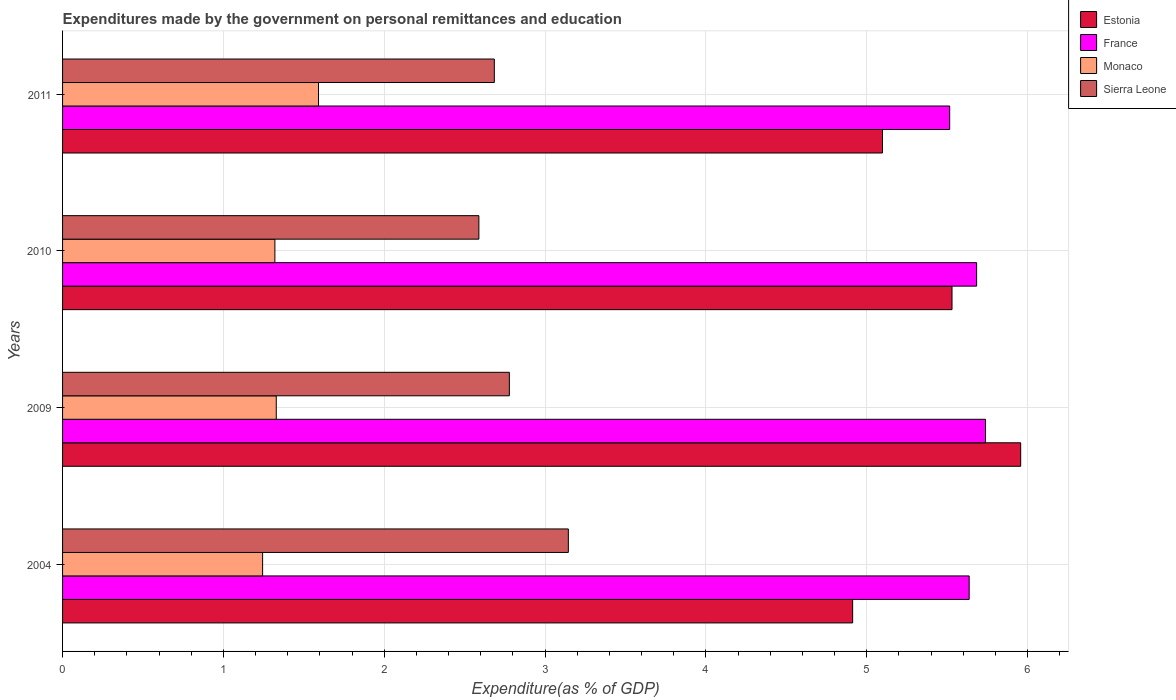How many groups of bars are there?
Give a very brief answer. 4. Are the number of bars per tick equal to the number of legend labels?
Give a very brief answer. Yes. How many bars are there on the 2nd tick from the bottom?
Offer a very short reply. 4. What is the expenditures made by the government on personal remittances and education in Estonia in 2011?
Offer a very short reply. 5.1. Across all years, what is the maximum expenditures made by the government on personal remittances and education in Sierra Leone?
Ensure brevity in your answer.  3.14. Across all years, what is the minimum expenditures made by the government on personal remittances and education in Sierra Leone?
Make the answer very short. 2.59. In which year was the expenditures made by the government on personal remittances and education in France maximum?
Provide a short and direct response. 2009. What is the total expenditures made by the government on personal remittances and education in Estonia in the graph?
Make the answer very short. 21.5. What is the difference between the expenditures made by the government on personal remittances and education in Sierra Leone in 2004 and that in 2011?
Your answer should be compact. 0.46. What is the difference between the expenditures made by the government on personal remittances and education in Sierra Leone in 2004 and the expenditures made by the government on personal remittances and education in Monaco in 2011?
Offer a terse response. 1.55. What is the average expenditures made by the government on personal remittances and education in Monaco per year?
Provide a succinct answer. 1.37. In the year 2004, what is the difference between the expenditures made by the government on personal remittances and education in France and expenditures made by the government on personal remittances and education in Monaco?
Your answer should be very brief. 4.39. What is the ratio of the expenditures made by the government on personal remittances and education in Sierra Leone in 2004 to that in 2009?
Offer a very short reply. 1.13. What is the difference between the highest and the second highest expenditures made by the government on personal remittances and education in France?
Your answer should be compact. 0.06. What is the difference between the highest and the lowest expenditures made by the government on personal remittances and education in Estonia?
Provide a succinct answer. 1.04. Is it the case that in every year, the sum of the expenditures made by the government on personal remittances and education in Monaco and expenditures made by the government on personal remittances and education in Estonia is greater than the sum of expenditures made by the government on personal remittances and education in France and expenditures made by the government on personal remittances and education in Sierra Leone?
Offer a very short reply. Yes. What does the 3rd bar from the top in 2010 represents?
Your answer should be very brief. France. What does the 1st bar from the bottom in 2009 represents?
Your answer should be very brief. Estonia. Are all the bars in the graph horizontal?
Offer a terse response. Yes. What is the difference between two consecutive major ticks on the X-axis?
Make the answer very short. 1. Are the values on the major ticks of X-axis written in scientific E-notation?
Give a very brief answer. No. Does the graph contain any zero values?
Provide a succinct answer. No. Where does the legend appear in the graph?
Your answer should be compact. Top right. How many legend labels are there?
Provide a short and direct response. 4. How are the legend labels stacked?
Your response must be concise. Vertical. What is the title of the graph?
Give a very brief answer. Expenditures made by the government on personal remittances and education. What is the label or title of the X-axis?
Offer a very short reply. Expenditure(as % of GDP). What is the Expenditure(as % of GDP) of Estonia in 2004?
Keep it short and to the point. 4.91. What is the Expenditure(as % of GDP) of France in 2004?
Provide a short and direct response. 5.64. What is the Expenditure(as % of GDP) of Monaco in 2004?
Offer a very short reply. 1.24. What is the Expenditure(as % of GDP) in Sierra Leone in 2004?
Provide a short and direct response. 3.14. What is the Expenditure(as % of GDP) in Estonia in 2009?
Offer a very short reply. 5.96. What is the Expenditure(as % of GDP) in France in 2009?
Provide a short and direct response. 5.74. What is the Expenditure(as % of GDP) in Monaco in 2009?
Offer a very short reply. 1.33. What is the Expenditure(as % of GDP) of Sierra Leone in 2009?
Keep it short and to the point. 2.78. What is the Expenditure(as % of GDP) in Estonia in 2010?
Keep it short and to the point. 5.53. What is the Expenditure(as % of GDP) of France in 2010?
Give a very brief answer. 5.68. What is the Expenditure(as % of GDP) in Monaco in 2010?
Provide a short and direct response. 1.32. What is the Expenditure(as % of GDP) in Sierra Leone in 2010?
Make the answer very short. 2.59. What is the Expenditure(as % of GDP) in Estonia in 2011?
Provide a short and direct response. 5.1. What is the Expenditure(as % of GDP) of France in 2011?
Your response must be concise. 5.52. What is the Expenditure(as % of GDP) of Monaco in 2011?
Your answer should be very brief. 1.59. What is the Expenditure(as % of GDP) of Sierra Leone in 2011?
Your response must be concise. 2.68. Across all years, what is the maximum Expenditure(as % of GDP) of Estonia?
Provide a succinct answer. 5.96. Across all years, what is the maximum Expenditure(as % of GDP) in France?
Provide a succinct answer. 5.74. Across all years, what is the maximum Expenditure(as % of GDP) of Monaco?
Your answer should be compact. 1.59. Across all years, what is the maximum Expenditure(as % of GDP) in Sierra Leone?
Ensure brevity in your answer.  3.14. Across all years, what is the minimum Expenditure(as % of GDP) of Estonia?
Your answer should be compact. 4.91. Across all years, what is the minimum Expenditure(as % of GDP) in France?
Give a very brief answer. 5.52. Across all years, what is the minimum Expenditure(as % of GDP) in Monaco?
Your response must be concise. 1.24. Across all years, what is the minimum Expenditure(as % of GDP) of Sierra Leone?
Offer a very short reply. 2.59. What is the total Expenditure(as % of GDP) of Estonia in the graph?
Provide a short and direct response. 21.5. What is the total Expenditure(as % of GDP) of France in the graph?
Make the answer very short. 22.57. What is the total Expenditure(as % of GDP) of Monaco in the graph?
Make the answer very short. 5.48. What is the total Expenditure(as % of GDP) in Sierra Leone in the graph?
Your answer should be compact. 11.2. What is the difference between the Expenditure(as % of GDP) of Estonia in 2004 and that in 2009?
Give a very brief answer. -1.04. What is the difference between the Expenditure(as % of GDP) of France in 2004 and that in 2009?
Make the answer very short. -0.1. What is the difference between the Expenditure(as % of GDP) of Monaco in 2004 and that in 2009?
Your answer should be compact. -0.08. What is the difference between the Expenditure(as % of GDP) of Sierra Leone in 2004 and that in 2009?
Give a very brief answer. 0.37. What is the difference between the Expenditure(as % of GDP) of Estonia in 2004 and that in 2010?
Provide a succinct answer. -0.62. What is the difference between the Expenditure(as % of GDP) in France in 2004 and that in 2010?
Provide a short and direct response. -0.05. What is the difference between the Expenditure(as % of GDP) of Monaco in 2004 and that in 2010?
Your response must be concise. -0.08. What is the difference between the Expenditure(as % of GDP) of Sierra Leone in 2004 and that in 2010?
Offer a terse response. 0.56. What is the difference between the Expenditure(as % of GDP) in Estonia in 2004 and that in 2011?
Your response must be concise. -0.19. What is the difference between the Expenditure(as % of GDP) of France in 2004 and that in 2011?
Keep it short and to the point. 0.12. What is the difference between the Expenditure(as % of GDP) in Monaco in 2004 and that in 2011?
Keep it short and to the point. -0.35. What is the difference between the Expenditure(as % of GDP) in Sierra Leone in 2004 and that in 2011?
Provide a short and direct response. 0.46. What is the difference between the Expenditure(as % of GDP) in Estonia in 2009 and that in 2010?
Keep it short and to the point. 0.43. What is the difference between the Expenditure(as % of GDP) of France in 2009 and that in 2010?
Your response must be concise. 0.06. What is the difference between the Expenditure(as % of GDP) of Monaco in 2009 and that in 2010?
Offer a very short reply. 0.01. What is the difference between the Expenditure(as % of GDP) in Sierra Leone in 2009 and that in 2010?
Your response must be concise. 0.19. What is the difference between the Expenditure(as % of GDP) in Estonia in 2009 and that in 2011?
Give a very brief answer. 0.86. What is the difference between the Expenditure(as % of GDP) in France in 2009 and that in 2011?
Give a very brief answer. 0.22. What is the difference between the Expenditure(as % of GDP) of Monaco in 2009 and that in 2011?
Provide a short and direct response. -0.26. What is the difference between the Expenditure(as % of GDP) in Sierra Leone in 2009 and that in 2011?
Your answer should be very brief. 0.09. What is the difference between the Expenditure(as % of GDP) in Estonia in 2010 and that in 2011?
Give a very brief answer. 0.43. What is the difference between the Expenditure(as % of GDP) in France in 2010 and that in 2011?
Ensure brevity in your answer.  0.17. What is the difference between the Expenditure(as % of GDP) in Monaco in 2010 and that in 2011?
Offer a terse response. -0.27. What is the difference between the Expenditure(as % of GDP) in Sierra Leone in 2010 and that in 2011?
Your answer should be very brief. -0.1. What is the difference between the Expenditure(as % of GDP) of Estonia in 2004 and the Expenditure(as % of GDP) of France in 2009?
Make the answer very short. -0.83. What is the difference between the Expenditure(as % of GDP) in Estonia in 2004 and the Expenditure(as % of GDP) in Monaco in 2009?
Ensure brevity in your answer.  3.58. What is the difference between the Expenditure(as % of GDP) in Estonia in 2004 and the Expenditure(as % of GDP) in Sierra Leone in 2009?
Make the answer very short. 2.13. What is the difference between the Expenditure(as % of GDP) in France in 2004 and the Expenditure(as % of GDP) in Monaco in 2009?
Provide a succinct answer. 4.31. What is the difference between the Expenditure(as % of GDP) in France in 2004 and the Expenditure(as % of GDP) in Sierra Leone in 2009?
Provide a succinct answer. 2.86. What is the difference between the Expenditure(as % of GDP) of Monaco in 2004 and the Expenditure(as % of GDP) of Sierra Leone in 2009?
Keep it short and to the point. -1.53. What is the difference between the Expenditure(as % of GDP) in Estonia in 2004 and the Expenditure(as % of GDP) in France in 2010?
Make the answer very short. -0.77. What is the difference between the Expenditure(as % of GDP) in Estonia in 2004 and the Expenditure(as % of GDP) in Monaco in 2010?
Ensure brevity in your answer.  3.59. What is the difference between the Expenditure(as % of GDP) in Estonia in 2004 and the Expenditure(as % of GDP) in Sierra Leone in 2010?
Provide a short and direct response. 2.32. What is the difference between the Expenditure(as % of GDP) in France in 2004 and the Expenditure(as % of GDP) in Monaco in 2010?
Make the answer very short. 4.32. What is the difference between the Expenditure(as % of GDP) of France in 2004 and the Expenditure(as % of GDP) of Sierra Leone in 2010?
Your answer should be very brief. 3.05. What is the difference between the Expenditure(as % of GDP) in Monaco in 2004 and the Expenditure(as % of GDP) in Sierra Leone in 2010?
Offer a very short reply. -1.34. What is the difference between the Expenditure(as % of GDP) of Estonia in 2004 and the Expenditure(as % of GDP) of France in 2011?
Provide a short and direct response. -0.6. What is the difference between the Expenditure(as % of GDP) in Estonia in 2004 and the Expenditure(as % of GDP) in Monaco in 2011?
Offer a terse response. 3.32. What is the difference between the Expenditure(as % of GDP) in Estonia in 2004 and the Expenditure(as % of GDP) in Sierra Leone in 2011?
Provide a short and direct response. 2.23. What is the difference between the Expenditure(as % of GDP) in France in 2004 and the Expenditure(as % of GDP) in Monaco in 2011?
Your answer should be very brief. 4.05. What is the difference between the Expenditure(as % of GDP) of France in 2004 and the Expenditure(as % of GDP) of Sierra Leone in 2011?
Ensure brevity in your answer.  2.95. What is the difference between the Expenditure(as % of GDP) in Monaco in 2004 and the Expenditure(as % of GDP) in Sierra Leone in 2011?
Provide a short and direct response. -1.44. What is the difference between the Expenditure(as % of GDP) in Estonia in 2009 and the Expenditure(as % of GDP) in France in 2010?
Make the answer very short. 0.27. What is the difference between the Expenditure(as % of GDP) of Estonia in 2009 and the Expenditure(as % of GDP) of Monaco in 2010?
Offer a terse response. 4.64. What is the difference between the Expenditure(as % of GDP) in Estonia in 2009 and the Expenditure(as % of GDP) in Sierra Leone in 2010?
Your answer should be compact. 3.37. What is the difference between the Expenditure(as % of GDP) of France in 2009 and the Expenditure(as % of GDP) of Monaco in 2010?
Provide a succinct answer. 4.42. What is the difference between the Expenditure(as % of GDP) of France in 2009 and the Expenditure(as % of GDP) of Sierra Leone in 2010?
Ensure brevity in your answer.  3.15. What is the difference between the Expenditure(as % of GDP) of Monaco in 2009 and the Expenditure(as % of GDP) of Sierra Leone in 2010?
Ensure brevity in your answer.  -1.26. What is the difference between the Expenditure(as % of GDP) of Estonia in 2009 and the Expenditure(as % of GDP) of France in 2011?
Provide a short and direct response. 0.44. What is the difference between the Expenditure(as % of GDP) in Estonia in 2009 and the Expenditure(as % of GDP) in Monaco in 2011?
Offer a very short reply. 4.37. What is the difference between the Expenditure(as % of GDP) of Estonia in 2009 and the Expenditure(as % of GDP) of Sierra Leone in 2011?
Offer a terse response. 3.27. What is the difference between the Expenditure(as % of GDP) in France in 2009 and the Expenditure(as % of GDP) in Monaco in 2011?
Your answer should be compact. 4.15. What is the difference between the Expenditure(as % of GDP) of France in 2009 and the Expenditure(as % of GDP) of Sierra Leone in 2011?
Provide a succinct answer. 3.05. What is the difference between the Expenditure(as % of GDP) of Monaco in 2009 and the Expenditure(as % of GDP) of Sierra Leone in 2011?
Give a very brief answer. -1.36. What is the difference between the Expenditure(as % of GDP) in Estonia in 2010 and the Expenditure(as % of GDP) in France in 2011?
Your response must be concise. 0.01. What is the difference between the Expenditure(as % of GDP) in Estonia in 2010 and the Expenditure(as % of GDP) in Monaco in 2011?
Your answer should be compact. 3.94. What is the difference between the Expenditure(as % of GDP) of Estonia in 2010 and the Expenditure(as % of GDP) of Sierra Leone in 2011?
Give a very brief answer. 2.85. What is the difference between the Expenditure(as % of GDP) in France in 2010 and the Expenditure(as % of GDP) in Monaco in 2011?
Your response must be concise. 4.09. What is the difference between the Expenditure(as % of GDP) of France in 2010 and the Expenditure(as % of GDP) of Sierra Leone in 2011?
Keep it short and to the point. 3. What is the difference between the Expenditure(as % of GDP) in Monaco in 2010 and the Expenditure(as % of GDP) in Sierra Leone in 2011?
Your response must be concise. -1.36. What is the average Expenditure(as % of GDP) of Estonia per year?
Ensure brevity in your answer.  5.37. What is the average Expenditure(as % of GDP) in France per year?
Make the answer very short. 5.64. What is the average Expenditure(as % of GDP) of Monaco per year?
Keep it short and to the point. 1.37. What is the average Expenditure(as % of GDP) in Sierra Leone per year?
Make the answer very short. 2.8. In the year 2004, what is the difference between the Expenditure(as % of GDP) in Estonia and Expenditure(as % of GDP) in France?
Give a very brief answer. -0.72. In the year 2004, what is the difference between the Expenditure(as % of GDP) of Estonia and Expenditure(as % of GDP) of Monaco?
Your response must be concise. 3.67. In the year 2004, what is the difference between the Expenditure(as % of GDP) in Estonia and Expenditure(as % of GDP) in Sierra Leone?
Keep it short and to the point. 1.77. In the year 2004, what is the difference between the Expenditure(as % of GDP) of France and Expenditure(as % of GDP) of Monaco?
Ensure brevity in your answer.  4.39. In the year 2004, what is the difference between the Expenditure(as % of GDP) of France and Expenditure(as % of GDP) of Sierra Leone?
Ensure brevity in your answer.  2.49. In the year 2004, what is the difference between the Expenditure(as % of GDP) in Monaco and Expenditure(as % of GDP) in Sierra Leone?
Your answer should be compact. -1.9. In the year 2009, what is the difference between the Expenditure(as % of GDP) of Estonia and Expenditure(as % of GDP) of France?
Offer a terse response. 0.22. In the year 2009, what is the difference between the Expenditure(as % of GDP) of Estonia and Expenditure(as % of GDP) of Monaco?
Give a very brief answer. 4.63. In the year 2009, what is the difference between the Expenditure(as % of GDP) in Estonia and Expenditure(as % of GDP) in Sierra Leone?
Your response must be concise. 3.18. In the year 2009, what is the difference between the Expenditure(as % of GDP) of France and Expenditure(as % of GDP) of Monaco?
Provide a succinct answer. 4.41. In the year 2009, what is the difference between the Expenditure(as % of GDP) of France and Expenditure(as % of GDP) of Sierra Leone?
Your answer should be very brief. 2.96. In the year 2009, what is the difference between the Expenditure(as % of GDP) of Monaco and Expenditure(as % of GDP) of Sierra Leone?
Provide a succinct answer. -1.45. In the year 2010, what is the difference between the Expenditure(as % of GDP) of Estonia and Expenditure(as % of GDP) of France?
Offer a very short reply. -0.15. In the year 2010, what is the difference between the Expenditure(as % of GDP) of Estonia and Expenditure(as % of GDP) of Monaco?
Your response must be concise. 4.21. In the year 2010, what is the difference between the Expenditure(as % of GDP) in Estonia and Expenditure(as % of GDP) in Sierra Leone?
Offer a very short reply. 2.94. In the year 2010, what is the difference between the Expenditure(as % of GDP) in France and Expenditure(as % of GDP) in Monaco?
Your answer should be very brief. 4.36. In the year 2010, what is the difference between the Expenditure(as % of GDP) of France and Expenditure(as % of GDP) of Sierra Leone?
Provide a short and direct response. 3.09. In the year 2010, what is the difference between the Expenditure(as % of GDP) in Monaco and Expenditure(as % of GDP) in Sierra Leone?
Your answer should be compact. -1.27. In the year 2011, what is the difference between the Expenditure(as % of GDP) of Estonia and Expenditure(as % of GDP) of France?
Offer a terse response. -0.42. In the year 2011, what is the difference between the Expenditure(as % of GDP) of Estonia and Expenditure(as % of GDP) of Monaco?
Give a very brief answer. 3.51. In the year 2011, what is the difference between the Expenditure(as % of GDP) in Estonia and Expenditure(as % of GDP) in Sierra Leone?
Your answer should be compact. 2.41. In the year 2011, what is the difference between the Expenditure(as % of GDP) of France and Expenditure(as % of GDP) of Monaco?
Make the answer very short. 3.92. In the year 2011, what is the difference between the Expenditure(as % of GDP) of France and Expenditure(as % of GDP) of Sierra Leone?
Your response must be concise. 2.83. In the year 2011, what is the difference between the Expenditure(as % of GDP) of Monaco and Expenditure(as % of GDP) of Sierra Leone?
Provide a succinct answer. -1.09. What is the ratio of the Expenditure(as % of GDP) of Estonia in 2004 to that in 2009?
Make the answer very short. 0.82. What is the ratio of the Expenditure(as % of GDP) of France in 2004 to that in 2009?
Ensure brevity in your answer.  0.98. What is the ratio of the Expenditure(as % of GDP) of Monaco in 2004 to that in 2009?
Keep it short and to the point. 0.94. What is the ratio of the Expenditure(as % of GDP) of Sierra Leone in 2004 to that in 2009?
Offer a very short reply. 1.13. What is the ratio of the Expenditure(as % of GDP) of Estonia in 2004 to that in 2010?
Provide a succinct answer. 0.89. What is the ratio of the Expenditure(as % of GDP) of Monaco in 2004 to that in 2010?
Offer a very short reply. 0.94. What is the ratio of the Expenditure(as % of GDP) in Sierra Leone in 2004 to that in 2010?
Your response must be concise. 1.21. What is the ratio of the Expenditure(as % of GDP) in Estonia in 2004 to that in 2011?
Your answer should be very brief. 0.96. What is the ratio of the Expenditure(as % of GDP) in Monaco in 2004 to that in 2011?
Give a very brief answer. 0.78. What is the ratio of the Expenditure(as % of GDP) of Sierra Leone in 2004 to that in 2011?
Your response must be concise. 1.17. What is the ratio of the Expenditure(as % of GDP) of Estonia in 2009 to that in 2010?
Your answer should be compact. 1.08. What is the ratio of the Expenditure(as % of GDP) of France in 2009 to that in 2010?
Provide a succinct answer. 1.01. What is the ratio of the Expenditure(as % of GDP) of Sierra Leone in 2009 to that in 2010?
Your answer should be very brief. 1.07. What is the ratio of the Expenditure(as % of GDP) in Estonia in 2009 to that in 2011?
Make the answer very short. 1.17. What is the ratio of the Expenditure(as % of GDP) in France in 2009 to that in 2011?
Ensure brevity in your answer.  1.04. What is the ratio of the Expenditure(as % of GDP) in Monaco in 2009 to that in 2011?
Your response must be concise. 0.83. What is the ratio of the Expenditure(as % of GDP) of Sierra Leone in 2009 to that in 2011?
Provide a short and direct response. 1.03. What is the ratio of the Expenditure(as % of GDP) of Estonia in 2010 to that in 2011?
Ensure brevity in your answer.  1.08. What is the ratio of the Expenditure(as % of GDP) in France in 2010 to that in 2011?
Offer a terse response. 1.03. What is the ratio of the Expenditure(as % of GDP) of Monaco in 2010 to that in 2011?
Keep it short and to the point. 0.83. What is the ratio of the Expenditure(as % of GDP) in Sierra Leone in 2010 to that in 2011?
Keep it short and to the point. 0.96. What is the difference between the highest and the second highest Expenditure(as % of GDP) of Estonia?
Offer a very short reply. 0.43. What is the difference between the highest and the second highest Expenditure(as % of GDP) of France?
Ensure brevity in your answer.  0.06. What is the difference between the highest and the second highest Expenditure(as % of GDP) in Monaco?
Offer a terse response. 0.26. What is the difference between the highest and the second highest Expenditure(as % of GDP) in Sierra Leone?
Offer a terse response. 0.37. What is the difference between the highest and the lowest Expenditure(as % of GDP) of Estonia?
Make the answer very short. 1.04. What is the difference between the highest and the lowest Expenditure(as % of GDP) in France?
Keep it short and to the point. 0.22. What is the difference between the highest and the lowest Expenditure(as % of GDP) of Monaco?
Provide a short and direct response. 0.35. What is the difference between the highest and the lowest Expenditure(as % of GDP) of Sierra Leone?
Your response must be concise. 0.56. 